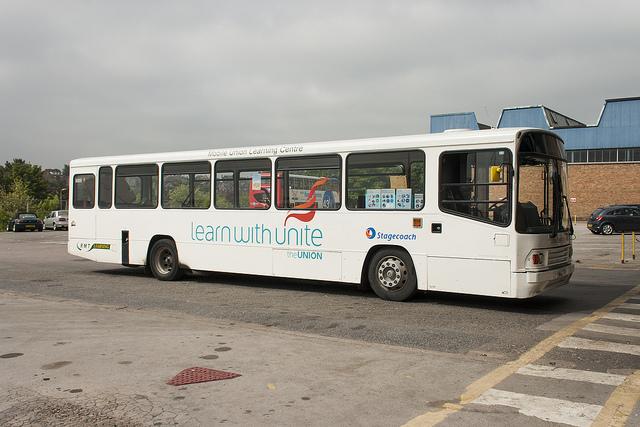How many people are on the bus?
Be succinct. 0. How many wheels does the bus have?
Give a very brief answer. 2. Is it a sunny day?
Answer briefly. No. What does the bus say?
Short answer required. Learn with unite. Does this bus have scrapes in the paint?
Short answer required. No. 